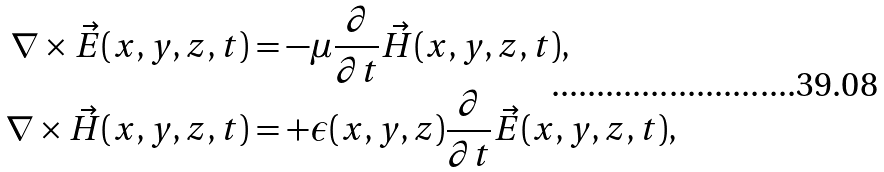<formula> <loc_0><loc_0><loc_500><loc_500>\nabla \times \vec { E } ( x , y , z , t ) & = - \mu \frac { \partial } { \partial t } \vec { H } ( x , y , z , t ) , \\ \nabla \times \vec { H } ( x , y , z , t ) & = + \epsilon ( x , y , z ) \frac { \partial } { \partial t } \vec { E } ( x , y , z , t ) ,</formula> 